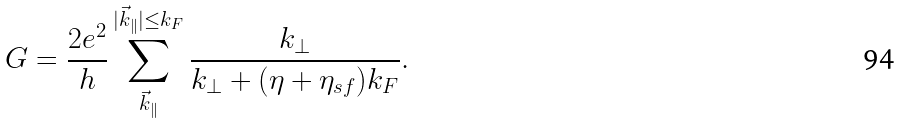Convert formula to latex. <formula><loc_0><loc_0><loc_500><loc_500>G = \frac { 2 e ^ { 2 } } h \sum _ { \vec { k } _ { \| } } ^ { | \vec { k } _ { \| } | \leq k _ { F } } \frac { k _ { \perp } } { k _ { \perp } + ( \eta + \eta _ { s f } ) k _ { F } } .</formula> 